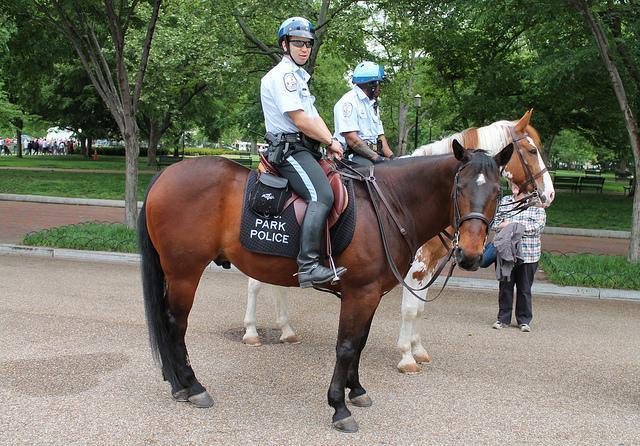How many people are visible?
Give a very brief answer. 3. How many horses can be seen?
Give a very brief answer. 2. 